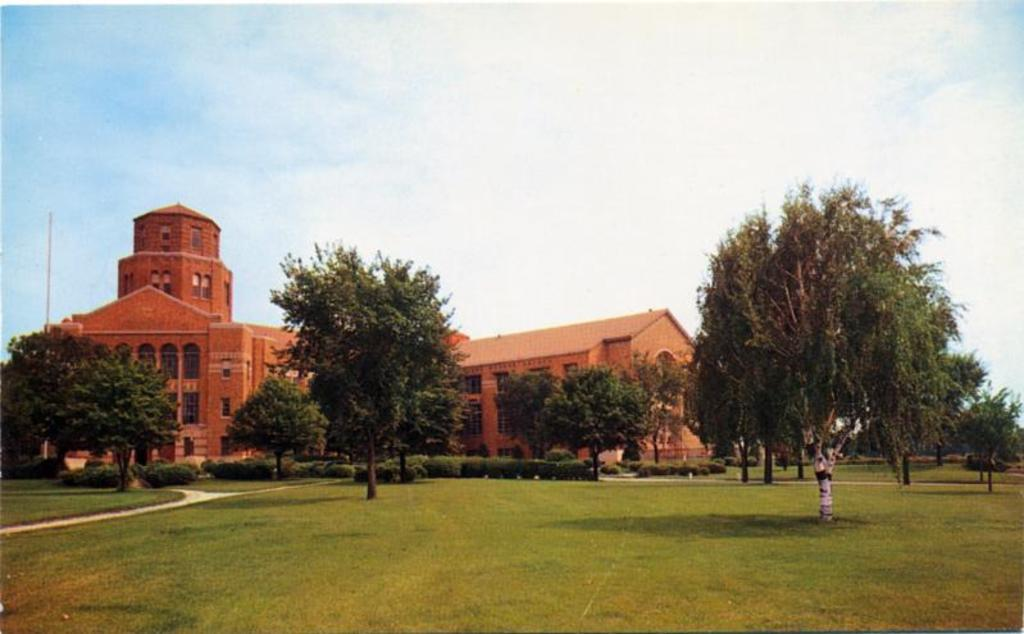What can be seen in the sky in the image? The sky with clouds is visible in the image. What type of structures can be seen in the image? There are buildings in the image. What type of vegetation is present in the image? Trees and bushes are visible in the image. What type of vertical structures are present in the image? Poles are present in the image. What type of surface is visible in the image? The ground is visible in the image. What type of path is visible in the image? There is a walking path in the image. What type of account does the sky have in the image? The sky does not have an account in the image; it is a natural element in the scene. What type of process is the walking path undergoing in the image? The walking path is not undergoing any process in the image; it is a stationary element in the scene. 